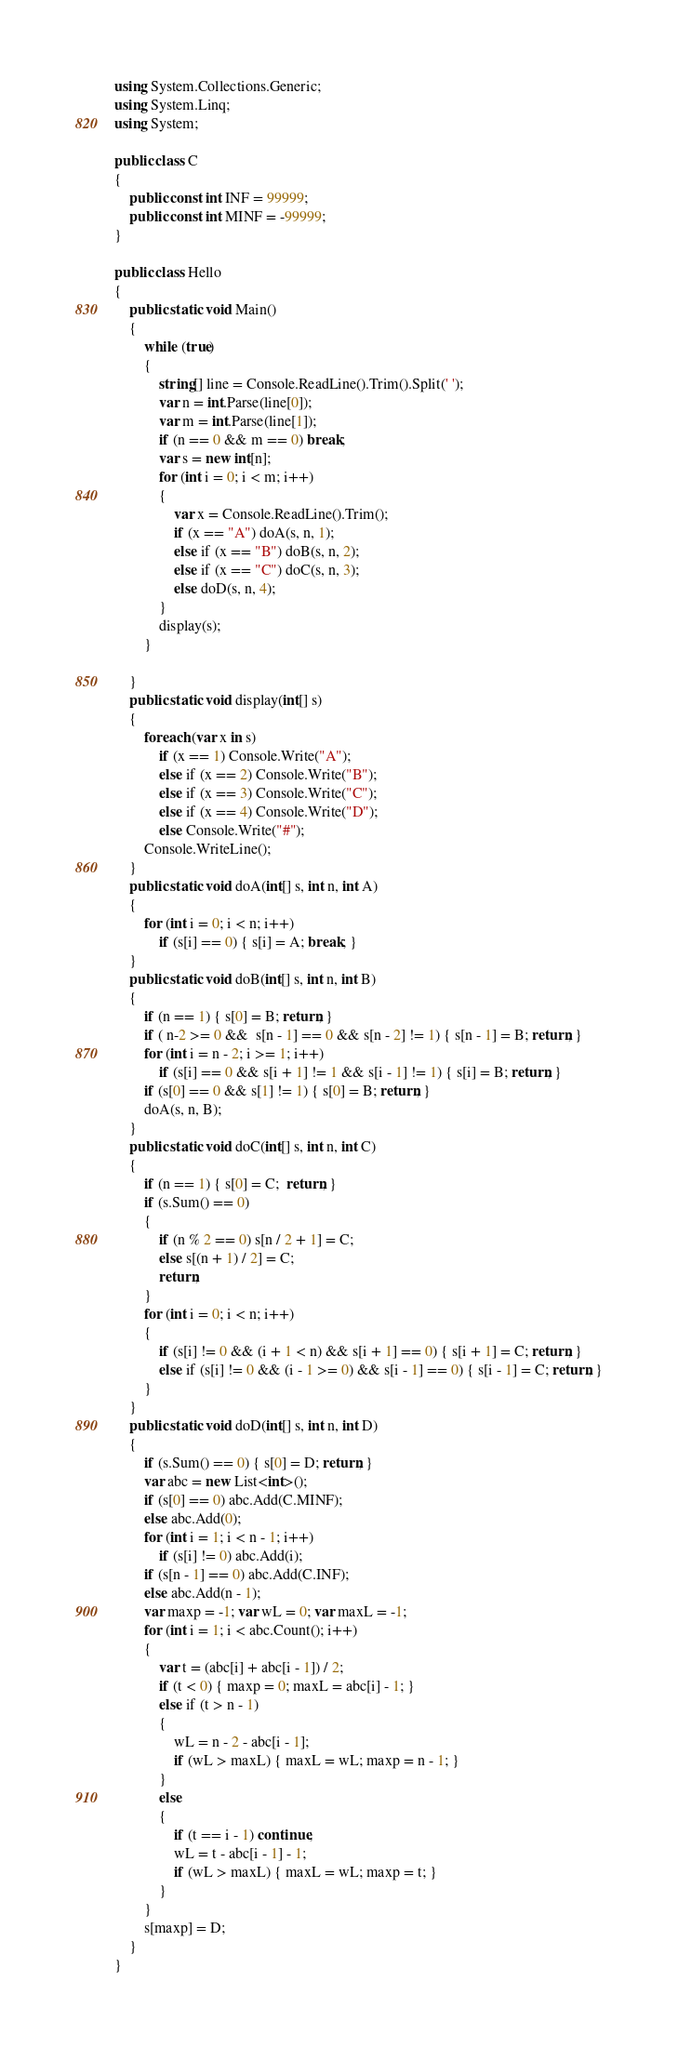<code> <loc_0><loc_0><loc_500><loc_500><_C#_>using System.Collections.Generic;
using System.Linq;
using System;

public class C
{
    public const int INF = 99999;
    public const int MINF = -99999;
}

public class Hello
{
    public static void Main()
    {
        while (true)
        {
            string[] line = Console.ReadLine().Trim().Split(' ');
            var n = int.Parse(line[0]);
            var m = int.Parse(line[1]);
            if (n == 0 && m == 0) break;
            var s = new int[n];
            for (int i = 0; i < m; i++)
            {
                var x = Console.ReadLine().Trim();
                if (x == "A") doA(s, n, 1);
                else if (x == "B") doB(s, n, 2);
                else if (x == "C") doC(s, n, 3);
                else doD(s, n, 4);
            }
            display(s);
        }

    }
    public static void display(int[] s)
    {
        foreach (var x in s)
            if (x == 1) Console.Write("A");
            else if (x == 2) Console.Write("B");
            else if (x == 3) Console.Write("C");
            else if (x == 4) Console.Write("D");
            else Console.Write("#");
        Console.WriteLine();
    }
    public static void doA(int[] s, int n, int A)
    {
        for (int i = 0; i < n; i++)
            if (s[i] == 0) { s[i] = A; break; }
    }
    public static void doB(int[] s, int n, int B)
    {
        if (n == 1) { s[0] = B; return; }
        if ( n-2 >= 0 &&  s[n - 1] == 0 && s[n - 2] != 1) { s[n - 1] = B; return; }
        for (int i = n - 2; i >= 1; i++)
            if (s[i] == 0 && s[i + 1] != 1 && s[i - 1] != 1) { s[i] = B; return; }
        if (s[0] == 0 && s[1] != 1) { s[0] = B; return; }
        doA(s, n, B);
    }
    public static void doC(int[] s, int n, int C)
    {
        if (n == 1) { s[0] = C;  return; }
        if (s.Sum() == 0)
        {
            if (n % 2 == 0) s[n / 2 + 1] = C;
            else s[(n + 1) / 2] = C;
            return;
        }
        for (int i = 0; i < n; i++)
        {
            if (s[i] != 0 && (i + 1 < n) && s[i + 1] == 0) { s[i + 1] = C; return; }
            else if (s[i] != 0 && (i - 1 >= 0) && s[i - 1] == 0) { s[i - 1] = C; return; }
        }
    }
    public static void doD(int[] s, int n, int D)
    {
        if (s.Sum() == 0) { s[0] = D; return; }
        var abc = new List<int>();
        if (s[0] == 0) abc.Add(C.MINF);
        else abc.Add(0);
        for (int i = 1; i < n - 1; i++)
            if (s[i] != 0) abc.Add(i);
        if (s[n - 1] == 0) abc.Add(C.INF);
        else abc.Add(n - 1);
        var maxp = -1; var wL = 0; var maxL = -1;
        for (int i = 1; i < abc.Count(); i++)
        {
            var t = (abc[i] + abc[i - 1]) / 2;
            if (t < 0) { maxp = 0; maxL = abc[i] - 1; }
            else if (t > n - 1)
            {
                wL = n - 2 - abc[i - 1];
                if (wL > maxL) { maxL = wL; maxp = n - 1; }
            }
            else
            {
                if (t == i - 1) continue;
                wL = t - abc[i - 1] - 1;
                if (wL > maxL) { maxL = wL; maxp = t; }
            }
        }
        s[maxp] = D;
    }
}</code> 